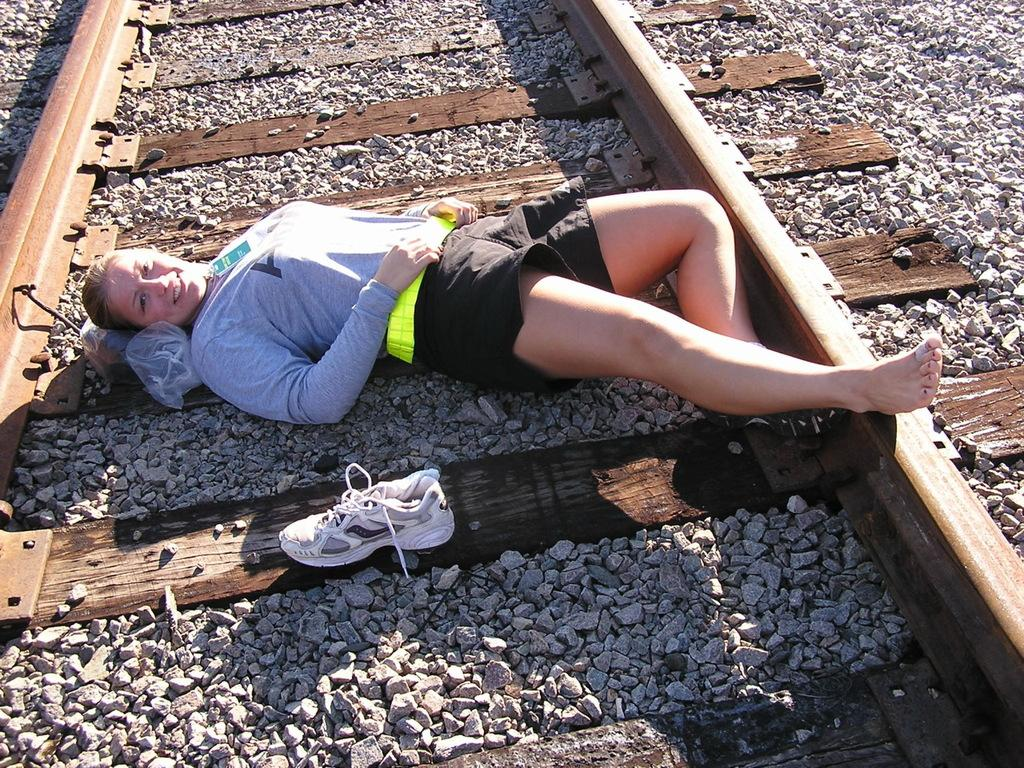Who is present in the image? There is a woman in the image. What is the woman doing in the image? The woman is sleeping on the track. What object is beside the woman? There is a shoe beside the woman. What type of surface can be seen in the image? There are stones visible in the image. What type of pleasure can be seen in the woman's face while sailing in the image? There is no indication of sailing or pleasure in the woman's face in the image; she is sleeping on the track. 